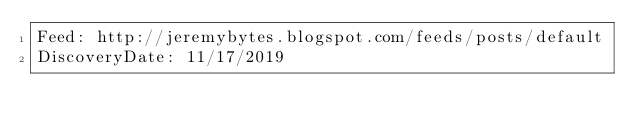<code> <loc_0><loc_0><loc_500><loc_500><_YAML_>Feed: http://jeremybytes.blogspot.com/feeds/posts/default
DiscoveryDate: 11/17/2019
</code> 